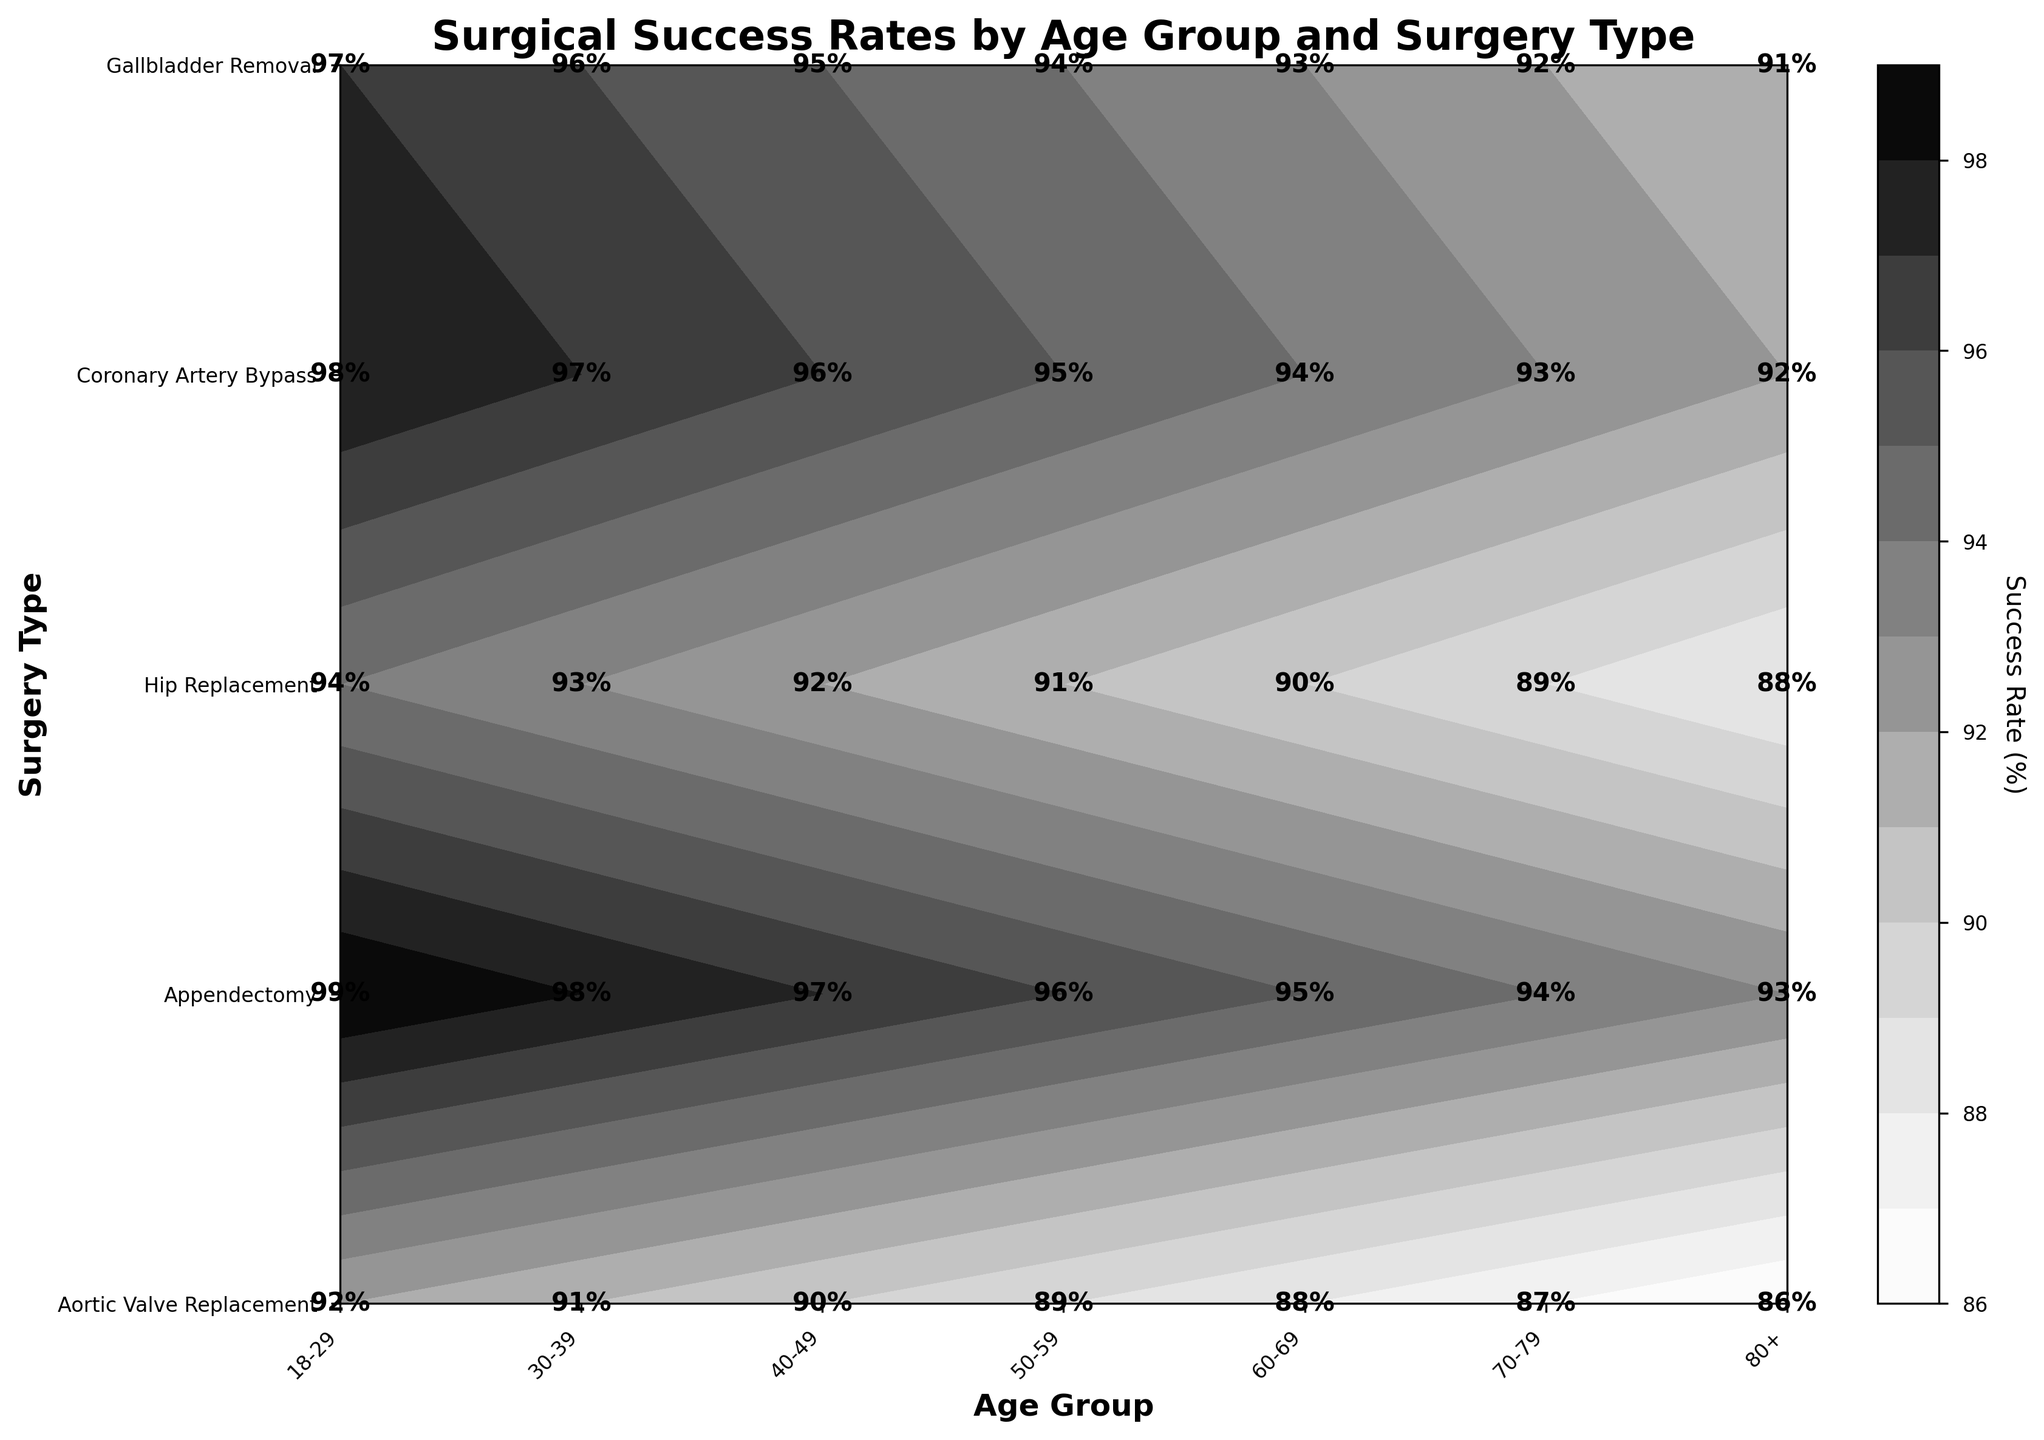What is the title of the figure? The title is usually displayed at the top of the figure. In this case, the title is clearly shown above the contour plot.
Answer: Surgical Success Rates by Age Group and Surgery Type What is the success rate for Aortic Valve Replacement in the 30-39 age group? Locate the intersection of the 30-39 age group and Aortic Valve Replacement on the plot. The success rate is annotated at that point.
Answer: 91% Which surgery type has the highest success rate in the 18-29 age group? Check the success rates for all surgery types within the 18-29 age group on the plot. Compare these values to find the highest one.
Answer: Appendectomy How does the success rate for Hip Replacement vary across age groups? Observe the contour levels for Hip Replacement across different age groups. The success rate decreases as the age group goes from younger to older.
Answer: It decreases What is the difference in success rates for Gallbladder Removal between the 50-59 and 60-69 age groups? Find the success rates for Gallbladder Removal in both the 50-59 and 60-69 age groups on the plot. Subtract the success rate of the 60-69 age group from that of the 50-59 age group.
Answer: 1% Which age group has the lowest success rate for Coronary Artery Bypass? Compare success rates for Coronary Artery Bypass across all age groups. Identify the age group with the lowest value.
Answer: 80+ Is there any age group where the success rate for Appendectomy is less than 95%? Review the success rates for Appendectomy across all age groups. Check if any value falls below 95%.
Answer: No What is the success rate trend for Aortic Valve Replacement from 18-29 to 80+ age groups? Observe the success rates for Aortic Valve Replacement as you move from the younger age group to the oldest. Note the changes in values.
Answer: It decreases Which surgery type has the least variation in success rate across the age groups? Examine the contour plot for each surgery type to find the one with the most consistent (least variable) success rate across all age groups.
Answer: Appendectomy Compare the success rates for Coronary Artery Bypass and Hip Replacement in the 40-49 age group. Which one is higher and by how much? Locate the success rates for both Coronary Artery Bypass and Hip Replacement within the 40-49 age group on the plot. Subtract the lower value from the higher one to find the difference.
Answer: Hip Replacement is higher by 3% 